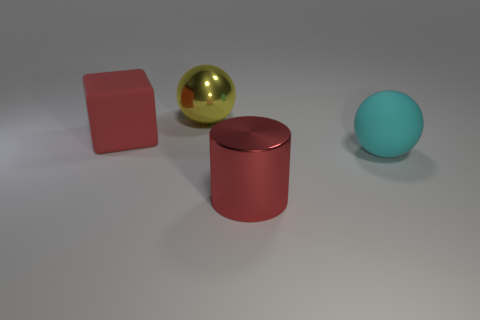Add 2 large yellow matte cylinders. How many objects exist? 6 Subtract all yellow balls. How many balls are left? 1 Subtract all cubes. How many objects are left? 3 Subtract all yellow cylinders. Subtract all gray cubes. How many cylinders are left? 1 Subtract all gray blocks. How many cyan spheres are left? 1 Subtract all yellow spheres. Subtract all big cyan matte balls. How many objects are left? 2 Add 2 red cubes. How many red cubes are left? 3 Add 1 cyan objects. How many cyan objects exist? 2 Subtract 0 purple cylinders. How many objects are left? 4 Subtract 1 blocks. How many blocks are left? 0 